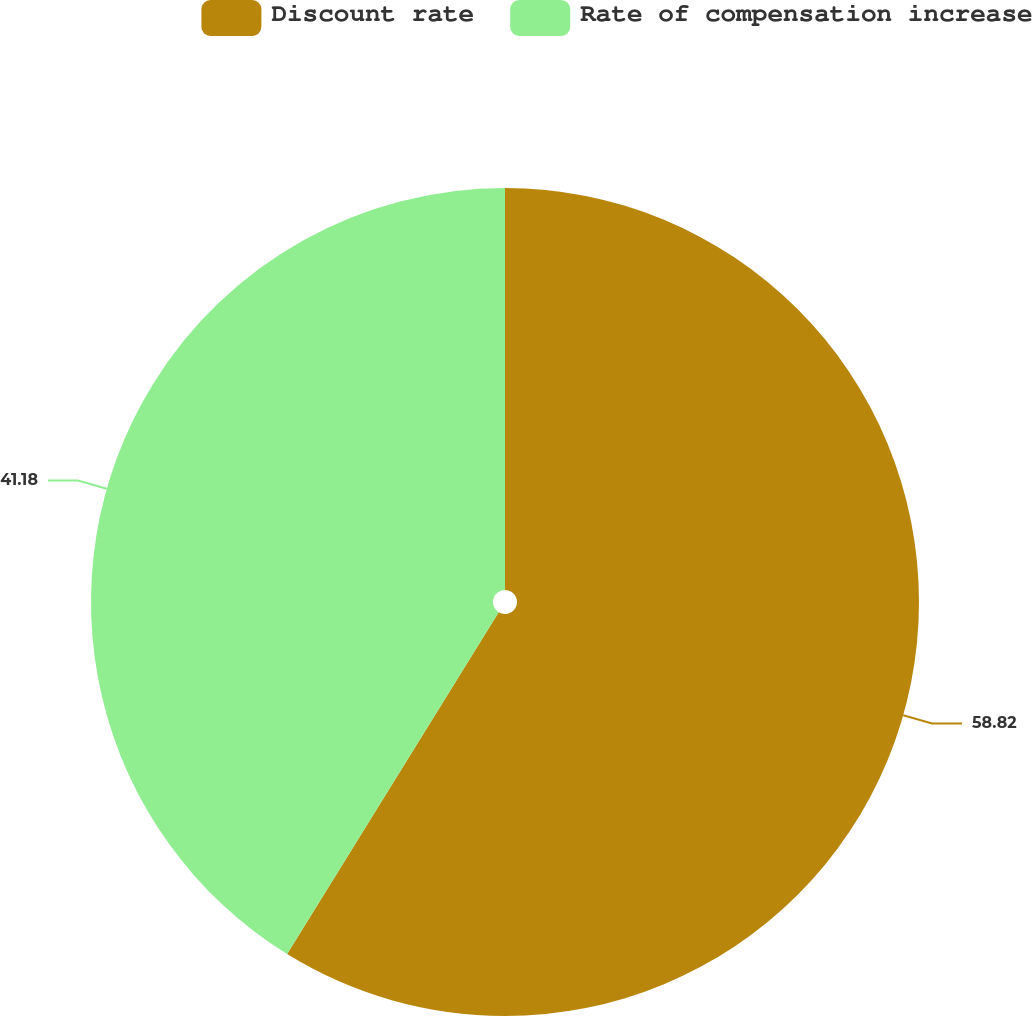Convert chart. <chart><loc_0><loc_0><loc_500><loc_500><pie_chart><fcel>Discount rate<fcel>Rate of compensation increase<nl><fcel>58.82%<fcel>41.18%<nl></chart> 